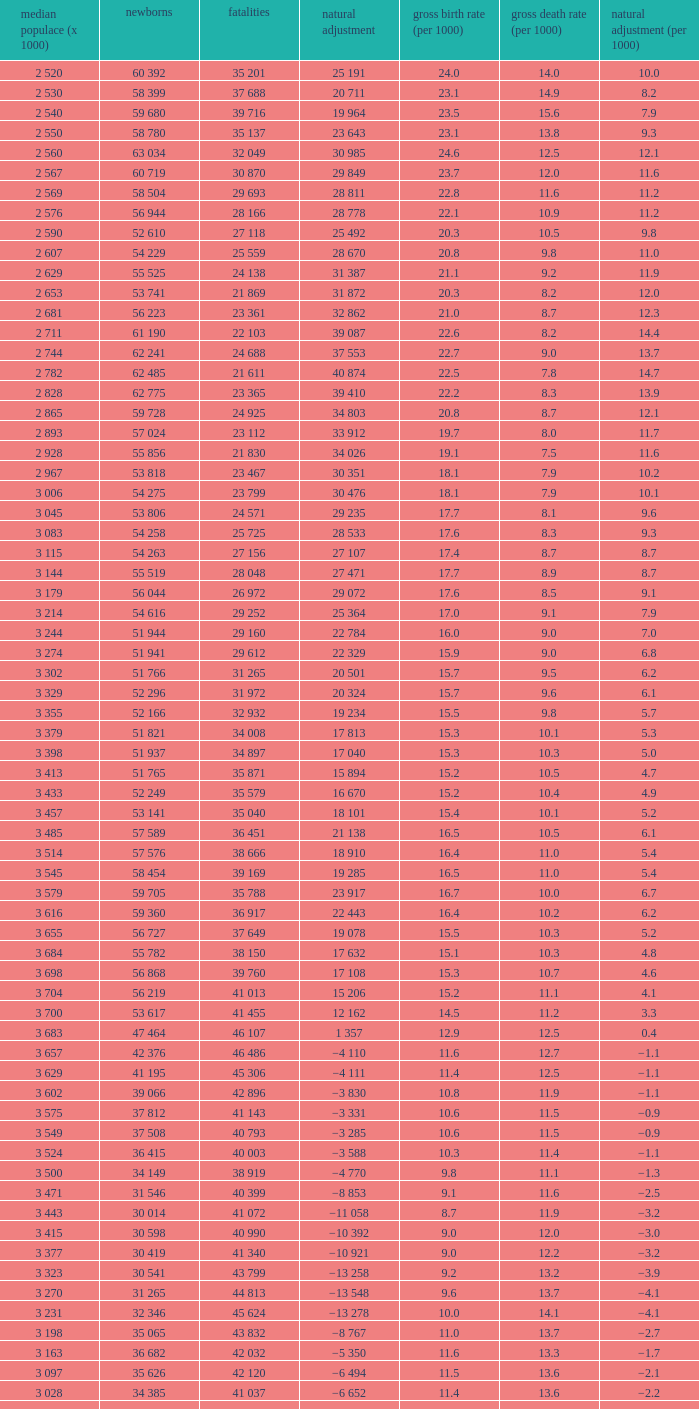Which Average population (x 1000) has a Crude death rate (per 1000) smaller than 10.9, and a Crude birth rate (per 1000) smaller than 19.7, and a Natural change (per 1000) of 8.7, and Live births of 54 263? 3 115. 